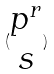<formula> <loc_0><loc_0><loc_500><loc_500>( \begin{matrix} p ^ { r } \\ s \end{matrix} )</formula> 